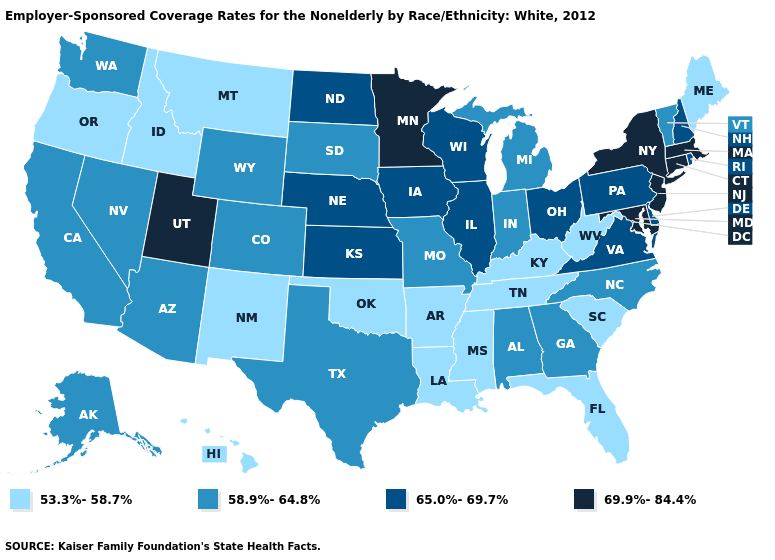Name the states that have a value in the range 53.3%-58.7%?
Keep it brief. Arkansas, Florida, Hawaii, Idaho, Kentucky, Louisiana, Maine, Mississippi, Montana, New Mexico, Oklahoma, Oregon, South Carolina, Tennessee, West Virginia. Which states have the highest value in the USA?
Give a very brief answer. Connecticut, Maryland, Massachusetts, Minnesota, New Jersey, New York, Utah. What is the value of Arizona?
Write a very short answer. 58.9%-64.8%. Does Connecticut have the highest value in the USA?
Answer briefly. Yes. What is the lowest value in the Northeast?
Write a very short answer. 53.3%-58.7%. What is the value of Michigan?
Quick response, please. 58.9%-64.8%. What is the lowest value in the Northeast?
Be succinct. 53.3%-58.7%. What is the value of Kentucky?
Quick response, please. 53.3%-58.7%. Does Vermont have the same value as Oregon?
Short answer required. No. Name the states that have a value in the range 65.0%-69.7%?
Write a very short answer. Delaware, Illinois, Iowa, Kansas, Nebraska, New Hampshire, North Dakota, Ohio, Pennsylvania, Rhode Island, Virginia, Wisconsin. Which states have the highest value in the USA?
Be succinct. Connecticut, Maryland, Massachusetts, Minnesota, New Jersey, New York, Utah. Which states have the lowest value in the USA?
Answer briefly. Arkansas, Florida, Hawaii, Idaho, Kentucky, Louisiana, Maine, Mississippi, Montana, New Mexico, Oklahoma, Oregon, South Carolina, Tennessee, West Virginia. Name the states that have a value in the range 65.0%-69.7%?
Keep it brief. Delaware, Illinois, Iowa, Kansas, Nebraska, New Hampshire, North Dakota, Ohio, Pennsylvania, Rhode Island, Virginia, Wisconsin. What is the lowest value in states that border Nebraska?
Give a very brief answer. 58.9%-64.8%. Name the states that have a value in the range 53.3%-58.7%?
Short answer required. Arkansas, Florida, Hawaii, Idaho, Kentucky, Louisiana, Maine, Mississippi, Montana, New Mexico, Oklahoma, Oregon, South Carolina, Tennessee, West Virginia. 